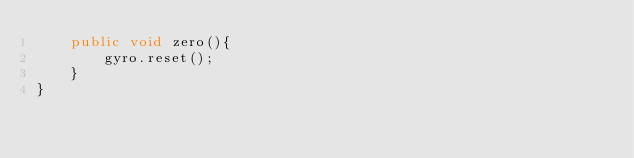Convert code to text. <code><loc_0><loc_0><loc_500><loc_500><_Java_>    public void zero(){
        gyro.reset();
    }
}
</code> 